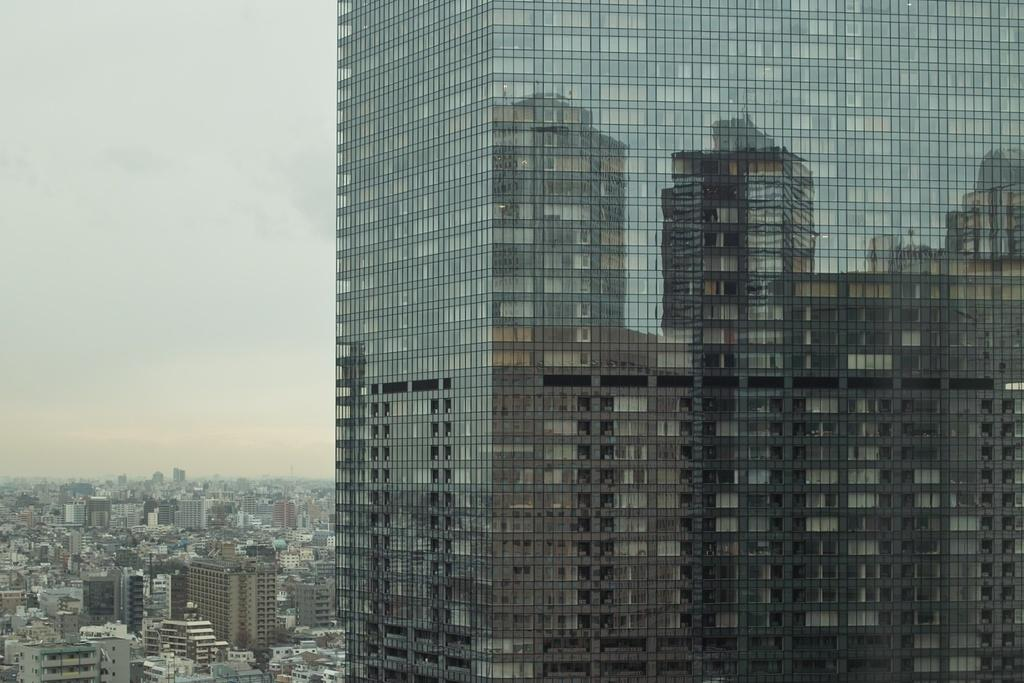What type of building is in the image? There is a glass building in the image. What can be seen on the glass of the building? There are reflections on the glass of the building. What is visible on the left side of the image? The sky, buildings, and trees are visible on the left side of the image. What letter is being delivered by the train in the image? There is no train present in the image, so it is not possible to answer that question. 